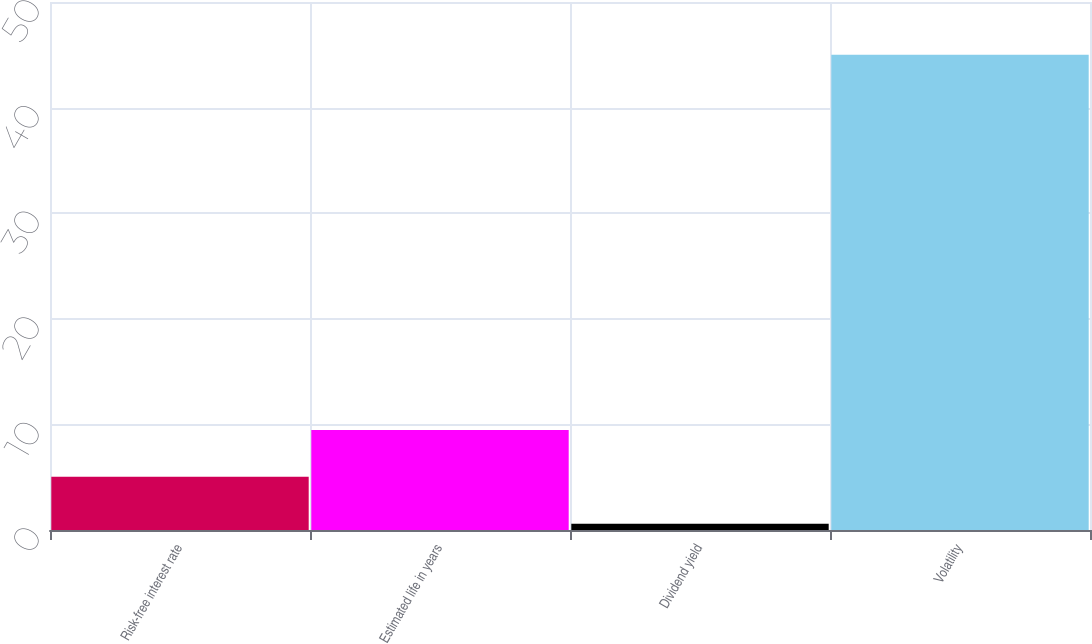<chart> <loc_0><loc_0><loc_500><loc_500><bar_chart><fcel>Risk-free interest rate<fcel>Estimated life in years<fcel>Dividend yield<fcel>Volatility<nl><fcel>5.04<fcel>9.48<fcel>0.6<fcel>45<nl></chart> 